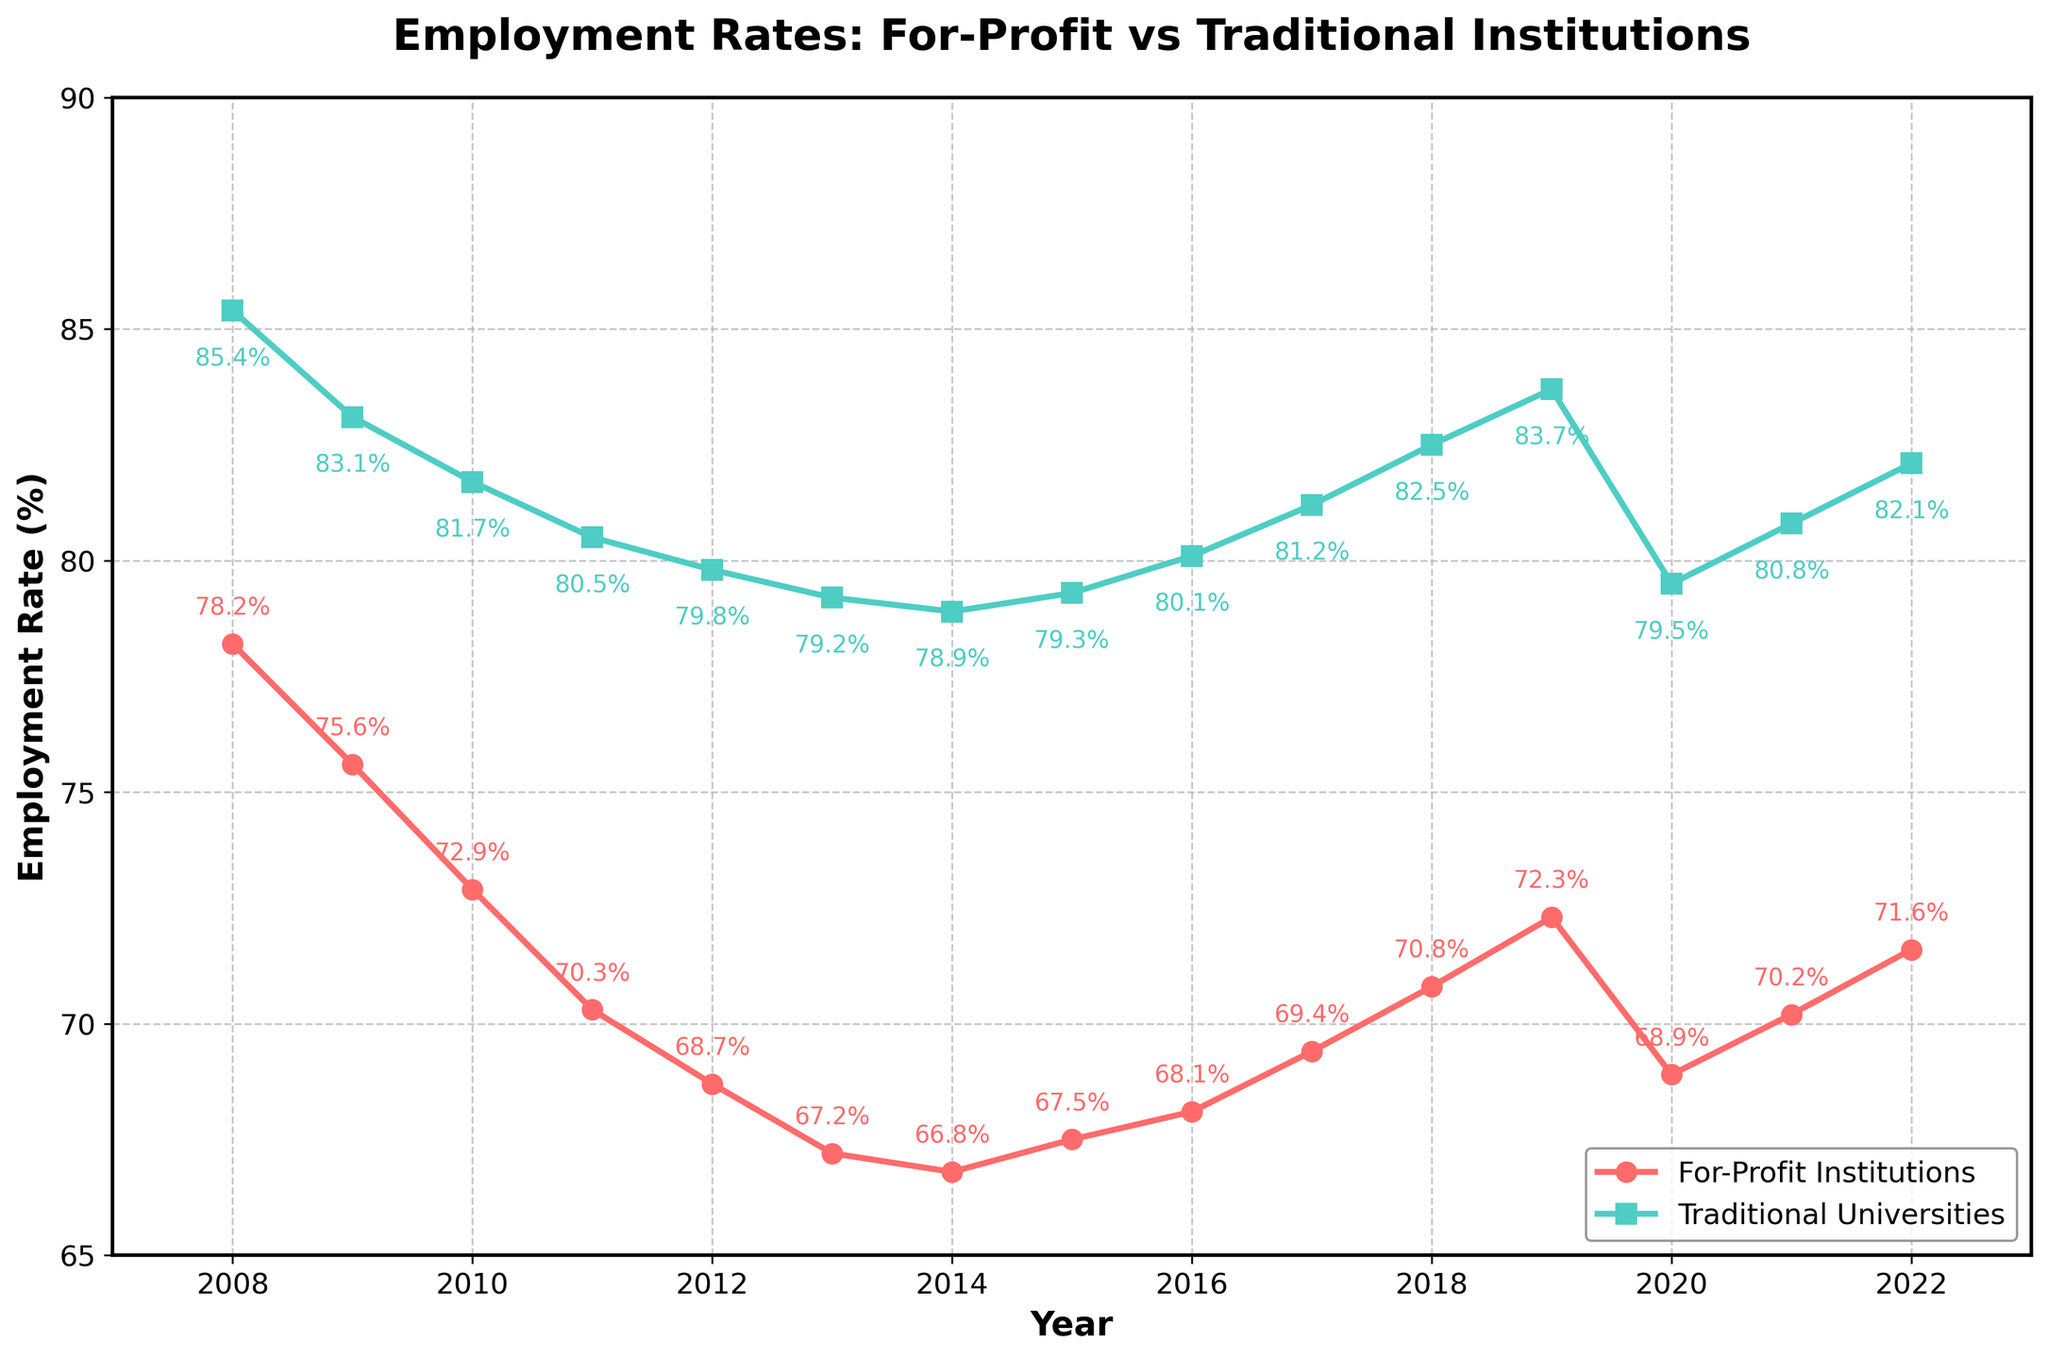What is the employment rate difference between for-profit institutions and traditional universities in 2008? To find the difference, subtract the employment rate of for-profit institutions in 2008 (78.2%) from that of traditional universities in 2008 (85.4%): 85.4% - 78.2%
Answer: 7.2% Which type of institution had a higher employment rate in 2015? Compare the employment rates of for-profit institutions and traditional universities in 2015: For-profit institutions had 67.5% and traditional universities had 79.3%. Therefore, traditional universities had a higher employment rate.
Answer: Traditional universities In which year did for-profit institutions have the lowest employment rate? Look for the year with the lowest point on the for-profit institutions' line. That year is 2013, where the rate is 67.2%.
Answer: 2013 What is the average employment rate of for-profit institutions from 2008 to 2022? Calculate the average by summing the employment rates of for-profit institutions from 2008 to 2022 and dividing by the number of years (15). The sum is (78.2 + 75.6 + 72.9 + 70.3 + 68.7 + 67.2 + 66.8 + 67.5 + 68.1 + 69.4 + 70.8 + 72.3 + 68.9 + 70.2 + 71.6) = 1030.5, so the average is 1030.5 / 15
Answer: 68.7% How did the employment rates of traditional universities change between 2010 and 2017? Identify the employment rates of traditional universities in 2010 (81.7%) and 2017 (81.2%). Compute the difference: 2017 - 2010 results in 81.2% - 81.7%
Answer: Decreased by 0.5% Which year showed the maximum employment rate difference between for-profit institutions and traditional universities? Calculate the differences for each year and identify the maximum: 
2008: 7.2%, 2009: 7.5%, 2010: 8.8%, 2011: 10.2%, 2012: 11.1%, 2013: 12%, 2014: 12.1%, 2015: 11.8%, 2016: 12%, 2017: 11.8%, 2018: 11.7%, 2019: 11.4%, 2020: 10.6%, 2021: 10.6%, 2022: 10.5%. The maximum difference is 12.1% in 2014.
Answer: 2014 Which institution has a more consistent trend in employment rates over the years? By observing the lines, the traditional universities' employment rate shows a more consistent (less variable) upward and downward trend compared to the for-profit institutions, which show sharper declines and recoveries.
Answer: Traditional universities What color represents the line for for-profit institutions in the figure? Visually identify the color of the line representing for-profit institutions. That line is red.
Answer: Red During which period did the employment rate for for-profit institutions decline continuously before stabilizing or increasing? Focus on the period from 2008 to 2014 during which the for-profit institutions' line shows a continual decline from 78.2% to 66.8%. After 2014, the rate starts to stabilize or increase.
Answer: 2008-2014 